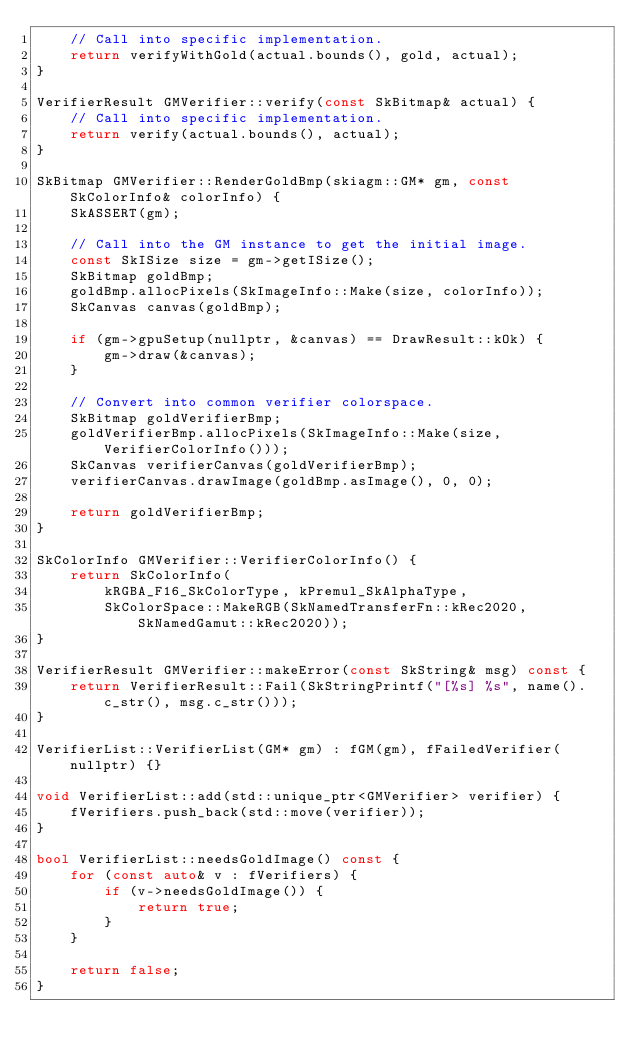<code> <loc_0><loc_0><loc_500><loc_500><_C++_>    // Call into specific implementation.
    return verifyWithGold(actual.bounds(), gold, actual);
}

VerifierResult GMVerifier::verify(const SkBitmap& actual) {
    // Call into specific implementation.
    return verify(actual.bounds(), actual);
}

SkBitmap GMVerifier::RenderGoldBmp(skiagm::GM* gm, const SkColorInfo& colorInfo) {
    SkASSERT(gm);

    // Call into the GM instance to get the initial image.
    const SkISize size = gm->getISize();
    SkBitmap goldBmp;
    goldBmp.allocPixels(SkImageInfo::Make(size, colorInfo));
    SkCanvas canvas(goldBmp);

    if (gm->gpuSetup(nullptr, &canvas) == DrawResult::kOk) {
        gm->draw(&canvas);
    }

    // Convert into common verifier colorspace.
    SkBitmap goldVerifierBmp;
    goldVerifierBmp.allocPixels(SkImageInfo::Make(size, VerifierColorInfo()));
    SkCanvas verifierCanvas(goldVerifierBmp);
    verifierCanvas.drawImage(goldBmp.asImage(), 0, 0);

    return goldVerifierBmp;
}

SkColorInfo GMVerifier::VerifierColorInfo() {
    return SkColorInfo(
        kRGBA_F16_SkColorType, kPremul_SkAlphaType,
        SkColorSpace::MakeRGB(SkNamedTransferFn::kRec2020, SkNamedGamut::kRec2020));
}

VerifierResult GMVerifier::makeError(const SkString& msg) const {
    return VerifierResult::Fail(SkStringPrintf("[%s] %s", name().c_str(), msg.c_str()));
}

VerifierList::VerifierList(GM* gm) : fGM(gm), fFailedVerifier(nullptr) {}

void VerifierList::add(std::unique_ptr<GMVerifier> verifier) {
    fVerifiers.push_back(std::move(verifier));
}

bool VerifierList::needsGoldImage() const {
    for (const auto& v : fVerifiers) {
        if (v->needsGoldImage()) {
            return true;
        }
    }

    return false;
}
</code> 